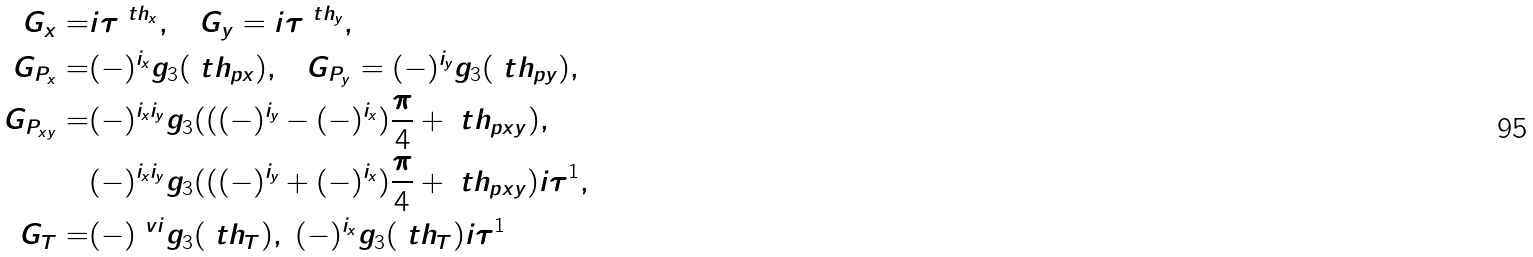Convert formula to latex. <formula><loc_0><loc_0><loc_500><loc_500>G _ { x } = & i \tau ^ { \ t h _ { x } } , \quad G _ { y } = i \tau ^ { \ t h _ { y } } , \\ G _ { P _ { x } } = & ( - ) ^ { i _ { x } } g _ { 3 } ( \ t h _ { p x } ) , \quad G _ { P _ { y } } = ( - ) ^ { i _ { y } } g _ { 3 } ( \ t h _ { p y } ) , \\ G _ { P _ { x y } } = & ( - ) ^ { i _ { x } i _ { y } } g _ { 3 } ( ( ( - ) ^ { i _ { y } } - ( - ) ^ { i _ { x } } ) \frac { \pi } { 4 } + \ t h _ { p x y } ) , \\ & ( - ) ^ { i _ { x } i _ { y } } g _ { 3 } ( ( ( - ) ^ { i _ { y } } + ( - ) ^ { i _ { x } } ) \frac { \pi } { 4 } + \ t h _ { p x y } ) i \tau ^ { 1 } , \\ G _ { T } = & ( - ) ^ { \ v i } g _ { 3 } ( \ t h _ { T } ) , \ ( - ) ^ { i _ { x } } g _ { 3 } ( \ t h _ { T } ) i \tau ^ { 1 }</formula> 